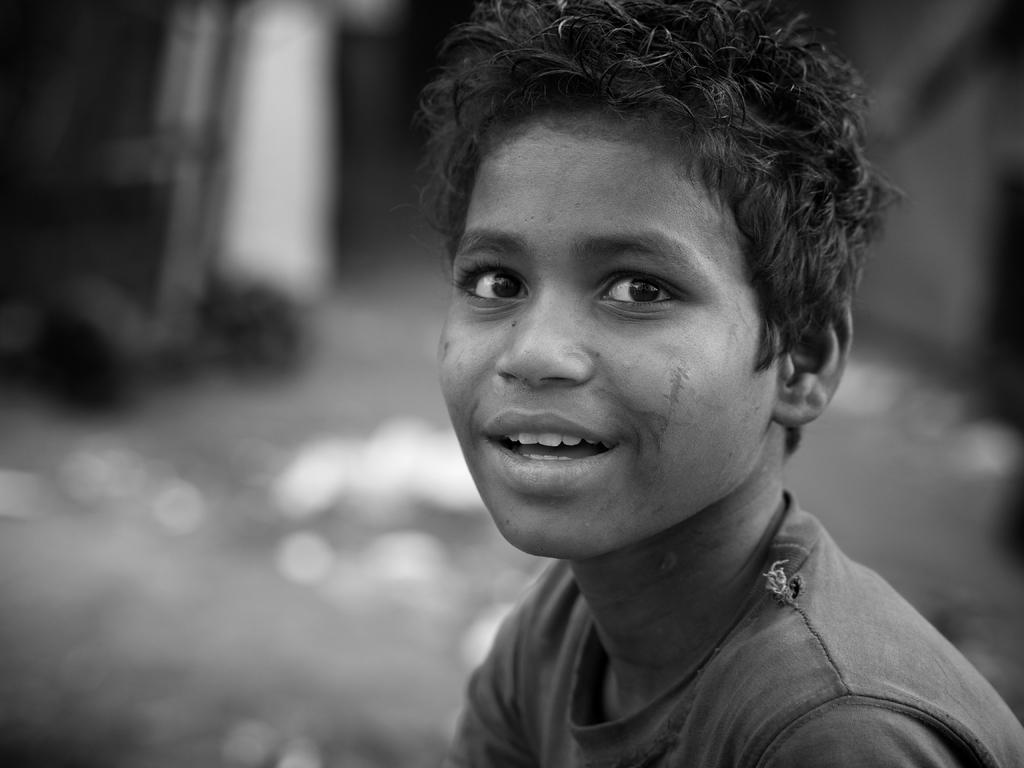What is the color scheme of the image? The image is black and white. Who is the main subject in the image? There is a boy in the image. What is the boy's expression in the image? The boy is smiling. What is the boy wearing in the image? The boy is wearing a T-shirt. How would you describe the background of the image? The background appears blurry. What type of chalk is the boy using to write on the government building in the image? There is no chalk or government building present in the image. 